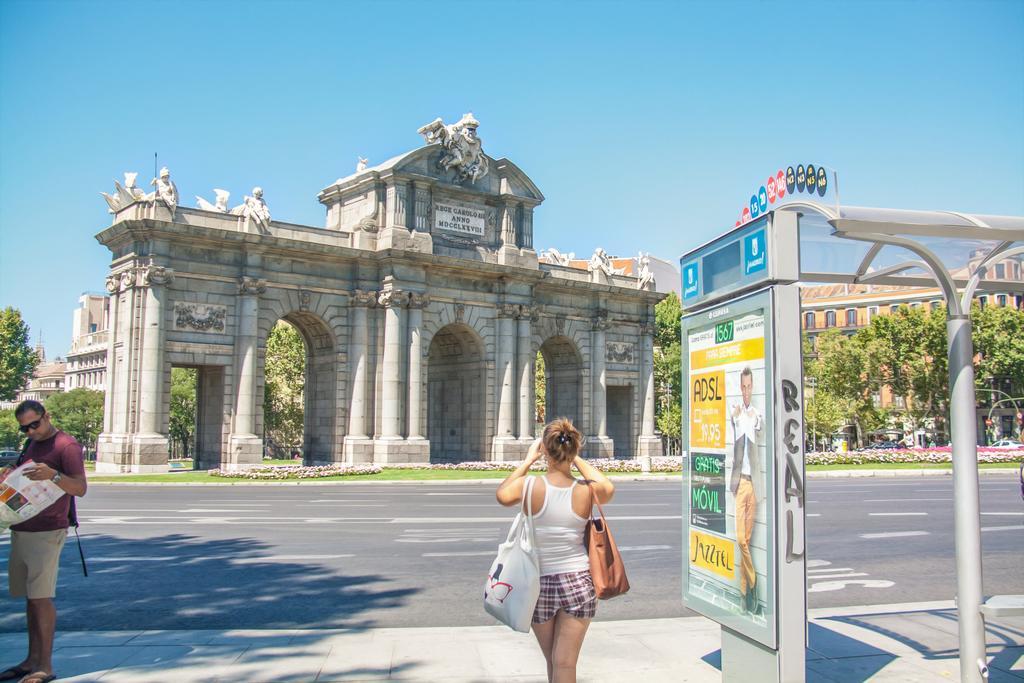Describe this image in one or two sentences. At the bottom of the image we can see a woman wearing bags. To the left side of the image we can see a person holding standing and holding a paper in his hands. On the right side of the image we can see a board with some text, shed, poles and some vehicles parked on the ground. In the center of the image we can see buildings with sculptures, group of trees. At the top of the image we can see the sky. 